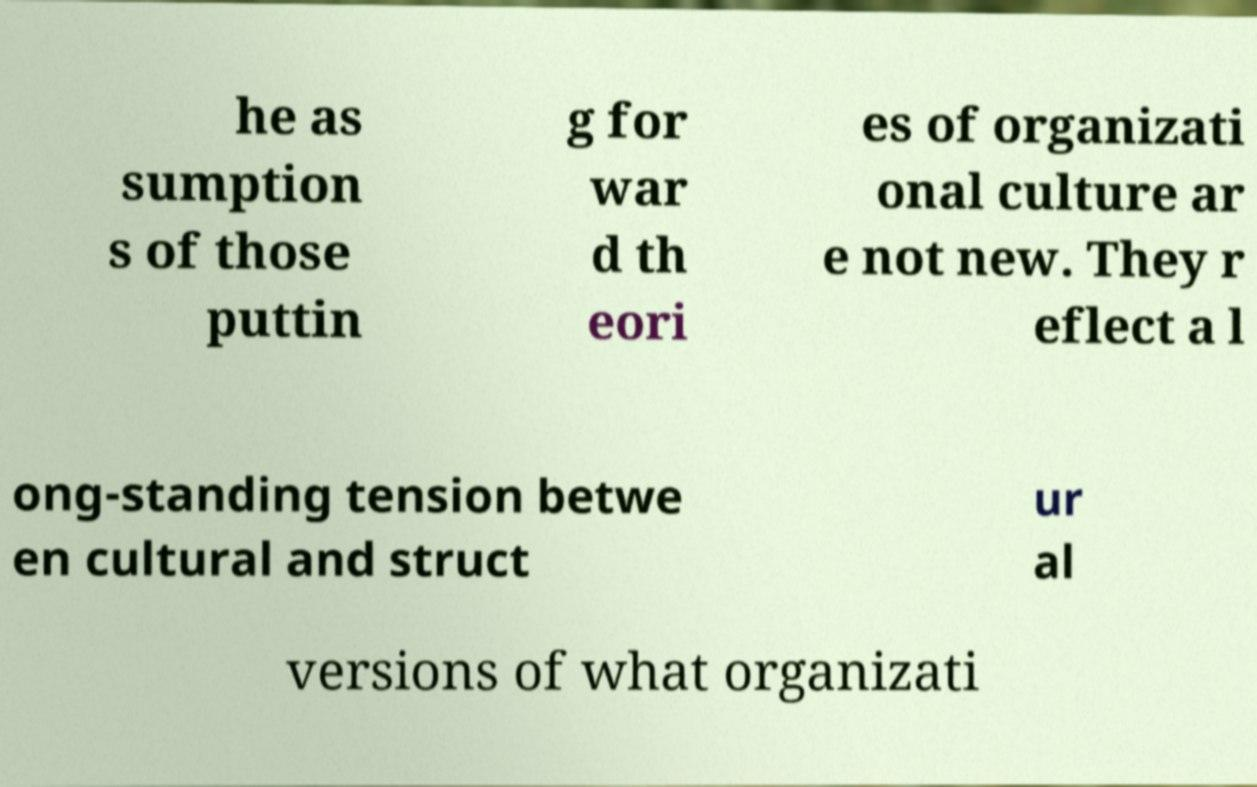Could you extract and type out the text from this image? he as sumption s of those puttin g for war d th eori es of organizati onal culture ar e not new. They r eflect a l ong-standing tension betwe en cultural and struct ur al versions of what organizati 